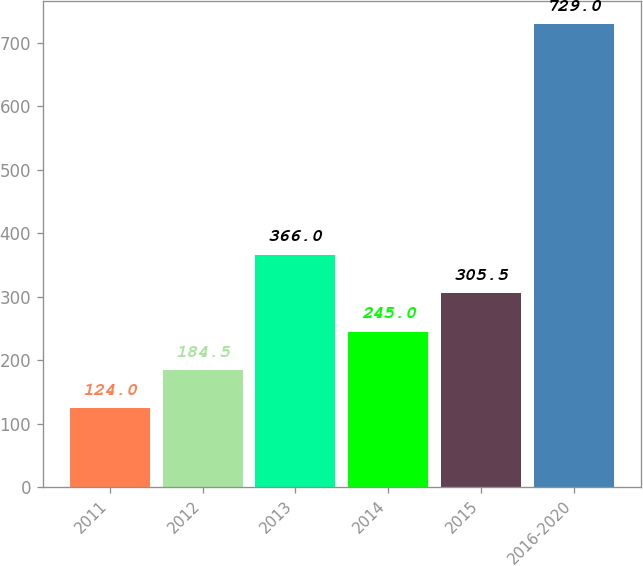Convert chart to OTSL. <chart><loc_0><loc_0><loc_500><loc_500><bar_chart><fcel>2011<fcel>2012<fcel>2013<fcel>2014<fcel>2015<fcel>2016-2020<nl><fcel>124<fcel>184.5<fcel>366<fcel>245<fcel>305.5<fcel>729<nl></chart> 